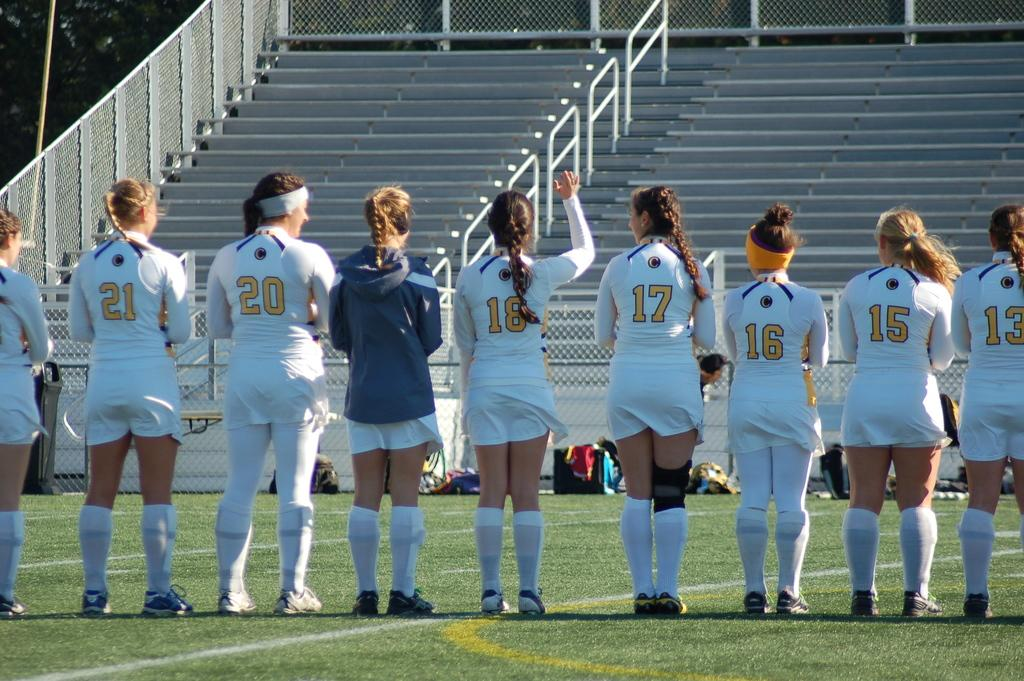<image>
Describe the image concisely. a few girls with one wearing the number 16 